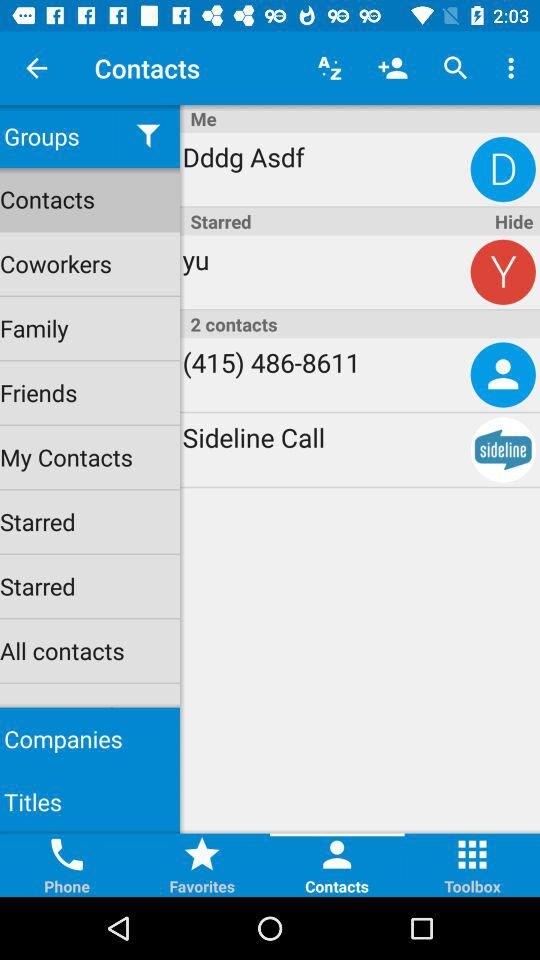Which tab is selected? The selected tab is "Contacts". 